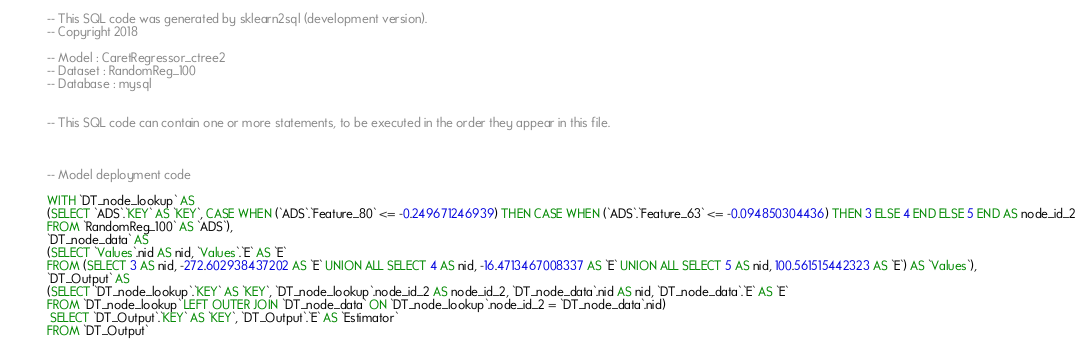Convert code to text. <code><loc_0><loc_0><loc_500><loc_500><_SQL_>-- This SQL code was generated by sklearn2sql (development version).
-- Copyright 2018

-- Model : CaretRegressor_ctree2
-- Dataset : RandomReg_100
-- Database : mysql


-- This SQL code can contain one or more statements, to be executed in the order they appear in this file.



-- Model deployment code

WITH `DT_node_lookup` AS 
(SELECT `ADS`.`KEY` AS `KEY`, CASE WHEN (`ADS`.`Feature_80` <= -0.249671246939) THEN CASE WHEN (`ADS`.`Feature_63` <= -0.094850304436) THEN 3 ELSE 4 END ELSE 5 END AS node_id_2 
FROM `RandomReg_100` AS `ADS`), 
`DT_node_data` AS 
(SELECT `Values`.nid AS nid, `Values`.`E` AS `E` 
FROM (SELECT 3 AS nid, -272.602938437202 AS `E` UNION ALL SELECT 4 AS nid, -16.4713467008337 AS `E` UNION ALL SELECT 5 AS nid, 100.561515442323 AS `E`) AS `Values`), 
`DT_Output` AS 
(SELECT `DT_node_lookup`.`KEY` AS `KEY`, `DT_node_lookup`.node_id_2 AS node_id_2, `DT_node_data`.nid AS nid, `DT_node_data`.`E` AS `E` 
FROM `DT_node_lookup` LEFT OUTER JOIN `DT_node_data` ON `DT_node_lookup`.node_id_2 = `DT_node_data`.nid)
 SELECT `DT_Output`.`KEY` AS `KEY`, `DT_Output`.`E` AS `Estimator` 
FROM `DT_Output`</code> 